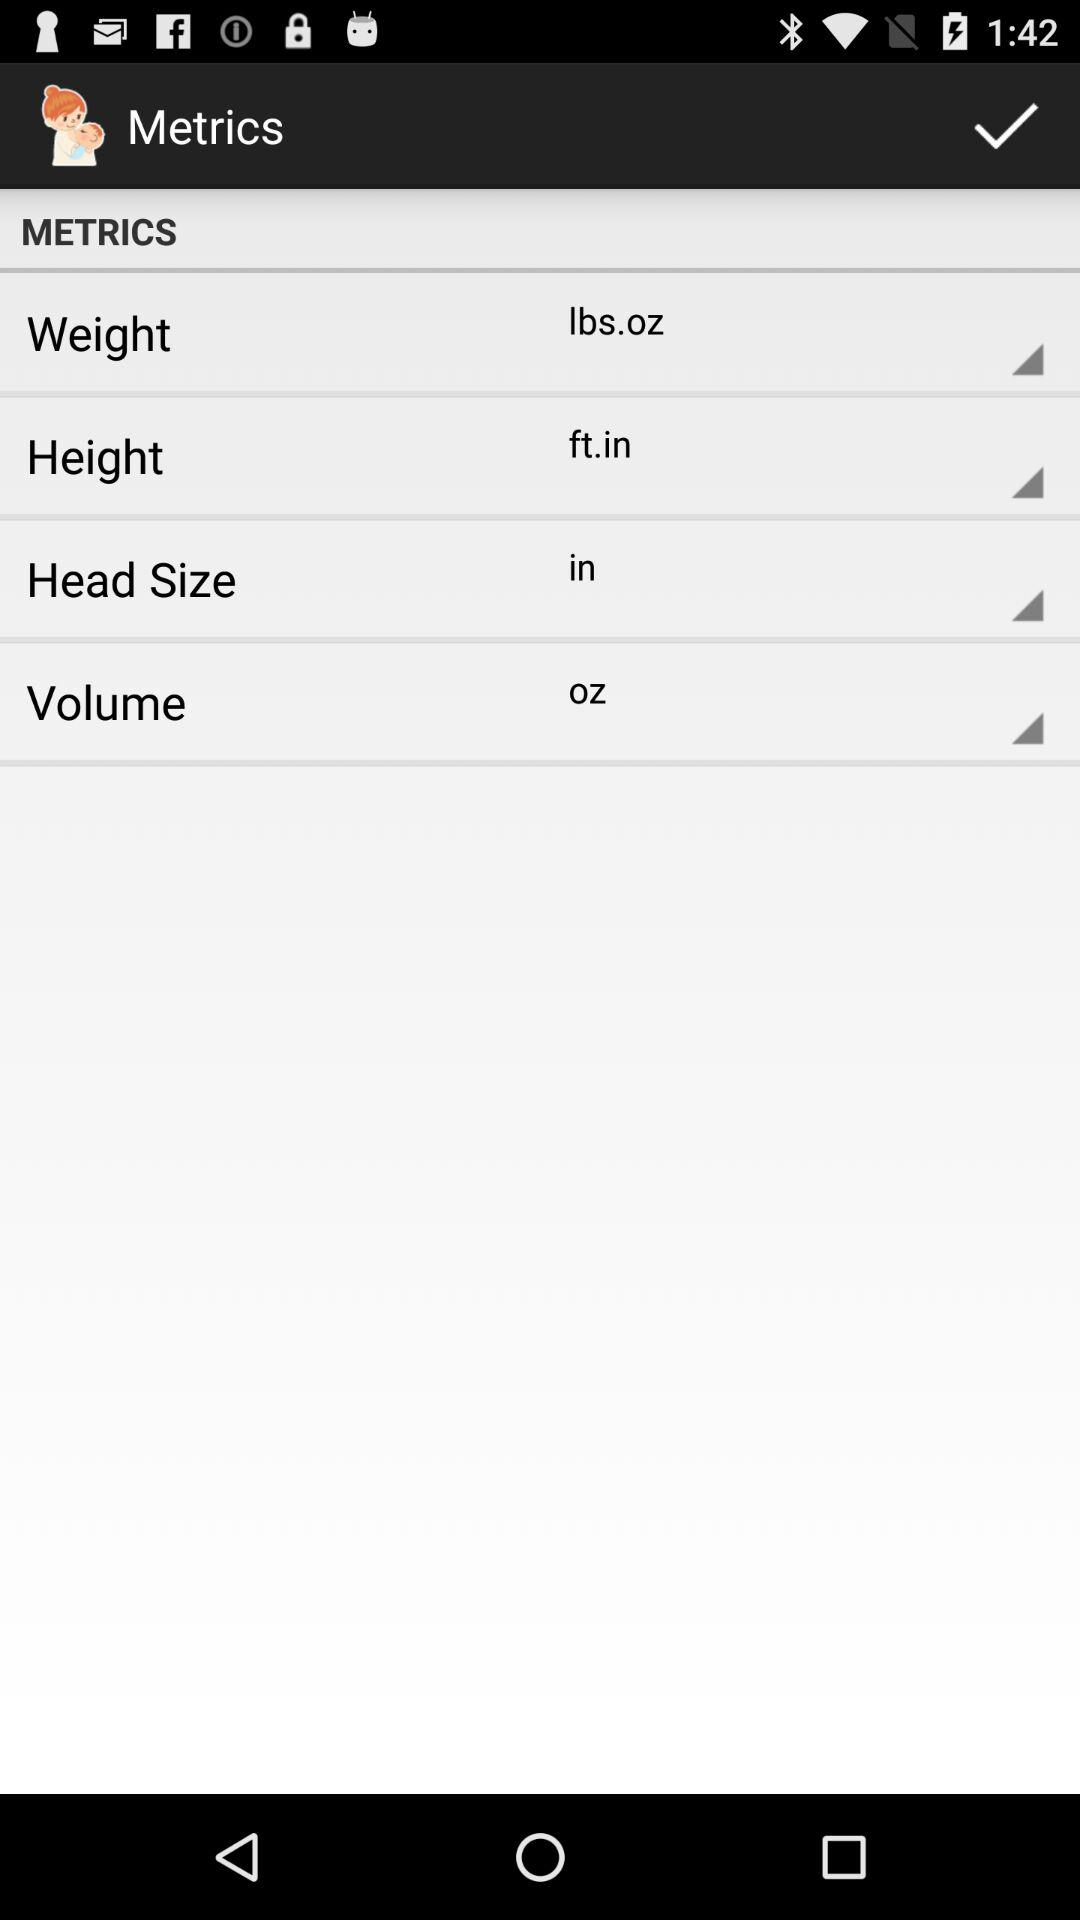What is the unit of height? The unit of height is feet and inches. 